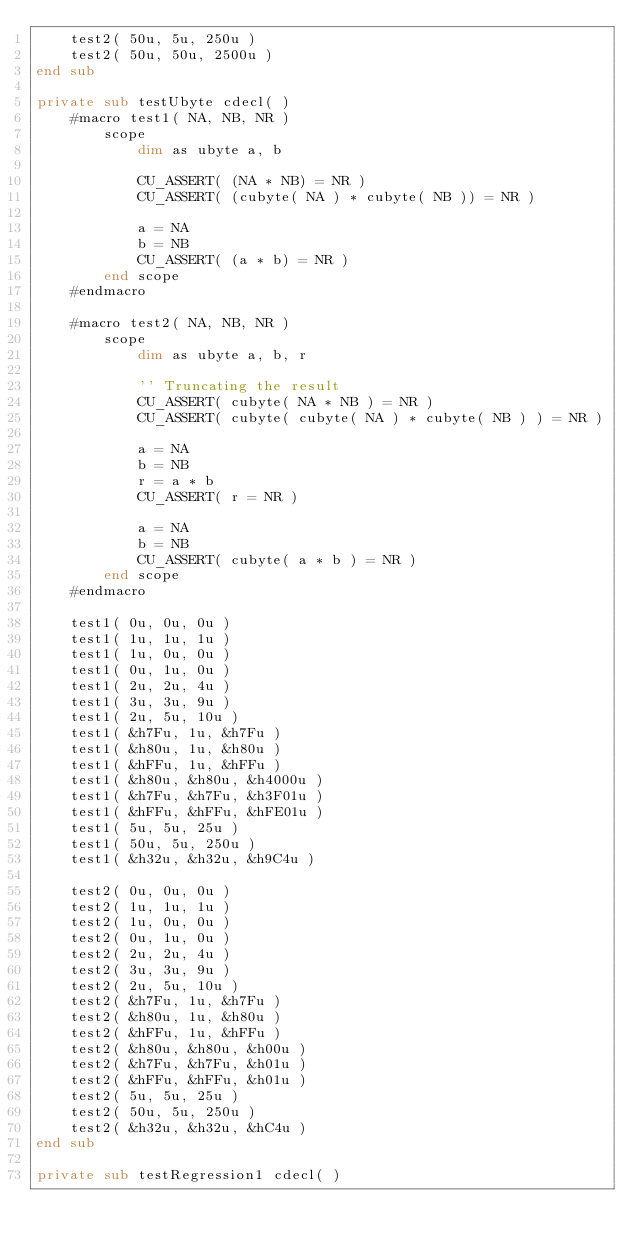Convert code to text. <code><loc_0><loc_0><loc_500><loc_500><_VisualBasic_>	test2( 50u, 5u, 250u )
	test2( 50u, 50u, 2500u )
end sub

private sub testUbyte cdecl( )
	#macro test1( NA, NB, NR )
		scope
			dim as ubyte a, b

			CU_ASSERT( (NA * NB) = NR )
			CU_ASSERT( (cubyte( NA ) * cubyte( NB )) = NR )

			a = NA
			b = NB
			CU_ASSERT( (a * b) = NR )
		end scope
	#endmacro

	#macro test2( NA, NB, NR )
		scope
			dim as ubyte a, b, r

			'' Truncating the result
			CU_ASSERT( cubyte( NA * NB ) = NR )
			CU_ASSERT( cubyte( cubyte( NA ) * cubyte( NB ) ) = NR )

			a = NA
			b = NB
			r = a * b
			CU_ASSERT( r = NR )

			a = NA
			b = NB
			CU_ASSERT( cubyte( a * b ) = NR )
		end scope
	#endmacro

	test1( 0u, 0u, 0u )
	test1( 1u, 1u, 1u )
	test1( 1u, 0u, 0u )
	test1( 0u, 1u, 0u )
	test1( 2u, 2u, 4u )
	test1( 3u, 3u, 9u )
	test1( 2u, 5u, 10u )
	test1( &h7Fu, 1u, &h7Fu )
	test1( &h80u, 1u, &h80u )
	test1( &hFFu, 1u, &hFFu )
	test1( &h80u, &h80u, &h4000u )
	test1( &h7Fu, &h7Fu, &h3F01u )
	test1( &hFFu, &hFFu, &hFE01u )
	test1( 5u, 5u, 25u )
	test1( 50u, 5u, 250u )
	test1( &h32u, &h32u, &h9C4u )

	test2( 0u, 0u, 0u )
	test2( 1u, 1u, 1u )
	test2( 1u, 0u, 0u )
	test2( 0u, 1u, 0u )
	test2( 2u, 2u, 4u )
	test2( 3u, 3u, 9u )
	test2( 2u, 5u, 10u )
	test2( &h7Fu, 1u, &h7Fu )
	test2( &h80u, 1u, &h80u )
	test2( &hFFu, 1u, &hFFu )
	test2( &h80u, &h80u, &h00u )
	test2( &h7Fu, &h7Fu, &h01u )
	test2( &hFFu, &hFFu, &h01u )
	test2( 5u, 5u, 25u )
	test2( 50u, 5u, 250u )
	test2( &h32u, &h32u, &hC4u )
end sub

private sub testRegression1 cdecl( )</code> 